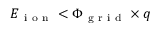Convert formula to latex. <formula><loc_0><loc_0><loc_500><loc_500>E _ { i o n } < \Phi _ { g r i d } \times q</formula> 